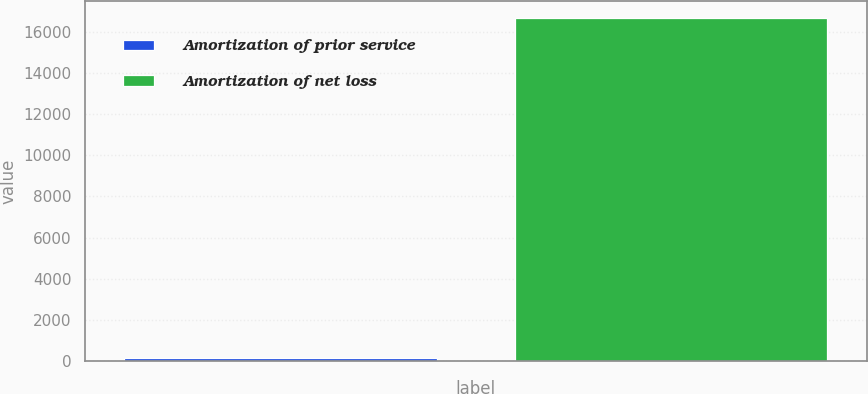Convert chart. <chart><loc_0><loc_0><loc_500><loc_500><bar_chart><fcel>Amortization of prior service<fcel>Amortization of net loss<nl><fcel>146<fcel>16660<nl></chart> 